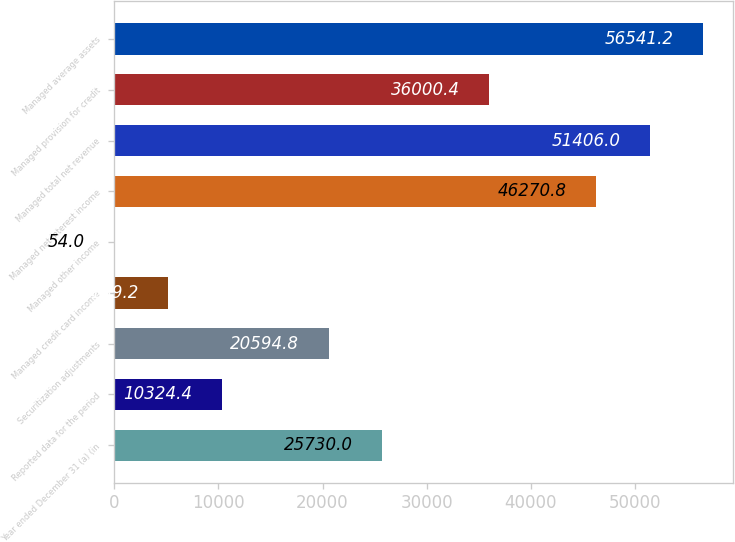<chart> <loc_0><loc_0><loc_500><loc_500><bar_chart><fcel>Year ended December 31 (a) (in<fcel>Reported data for the period<fcel>Securitization adjustments<fcel>Managed credit card income<fcel>Managed other income<fcel>Managed net interest income<fcel>Managed total net revenue<fcel>Managed provision for credit<fcel>Managed average assets<nl><fcel>25730<fcel>10324.4<fcel>20594.8<fcel>5189.2<fcel>54<fcel>46270.8<fcel>51406<fcel>36000.4<fcel>56541.2<nl></chart> 